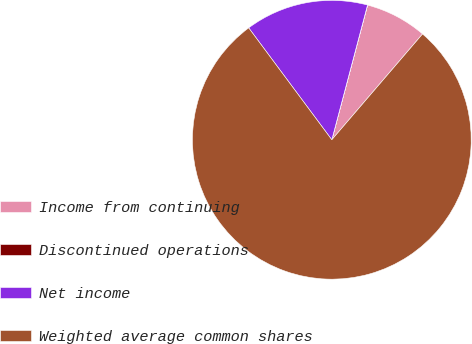Convert chart. <chart><loc_0><loc_0><loc_500><loc_500><pie_chart><fcel>Income from continuing<fcel>Discontinued operations<fcel>Net income<fcel>Weighted average common shares<nl><fcel>7.15%<fcel>0.01%<fcel>14.29%<fcel>78.55%<nl></chart> 